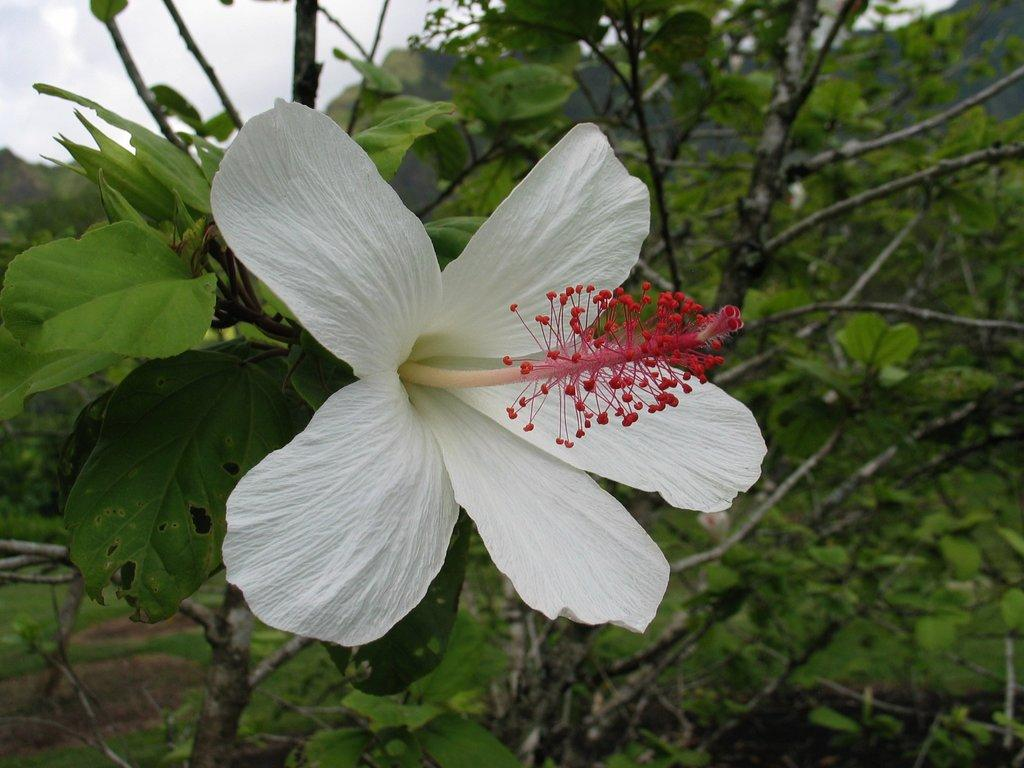What type of flower can be seen in the image? There is a white color flower in the image. What other elements are present on the right side of the image? There are plants and leaves on the right side of the image. What can be seen at the top left of the image? The sky is visible at the top left of the image. What is present in the sky? Clouds are present in the sky. How does the flower contribute to the digestion process in the image? The image does not depict any digestion process, and the flower is not involved in any such activity. 